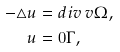<formula> <loc_0><loc_0><loc_500><loc_500>- \triangle u & = d i v \, v \Omega , \\ u & = 0 \Gamma ,</formula> 